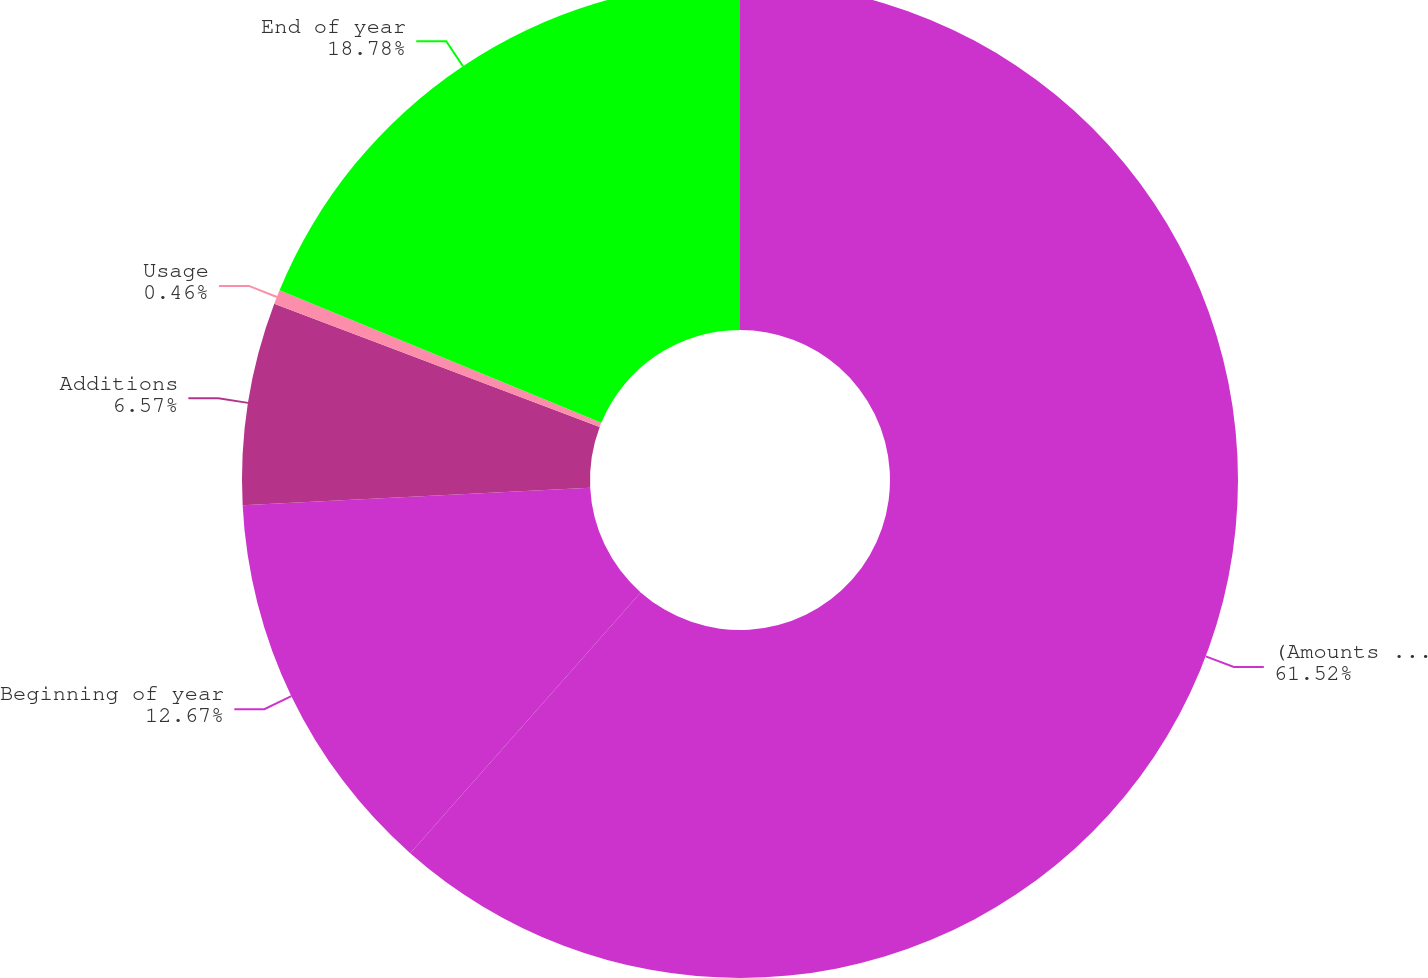Convert chart to OTSL. <chart><loc_0><loc_0><loc_500><loc_500><pie_chart><fcel>(Amounts in millions)<fcel>Beginning of year<fcel>Additions<fcel>Usage<fcel>End of year<nl><fcel>61.52%<fcel>12.67%<fcel>6.57%<fcel>0.46%<fcel>18.78%<nl></chart> 